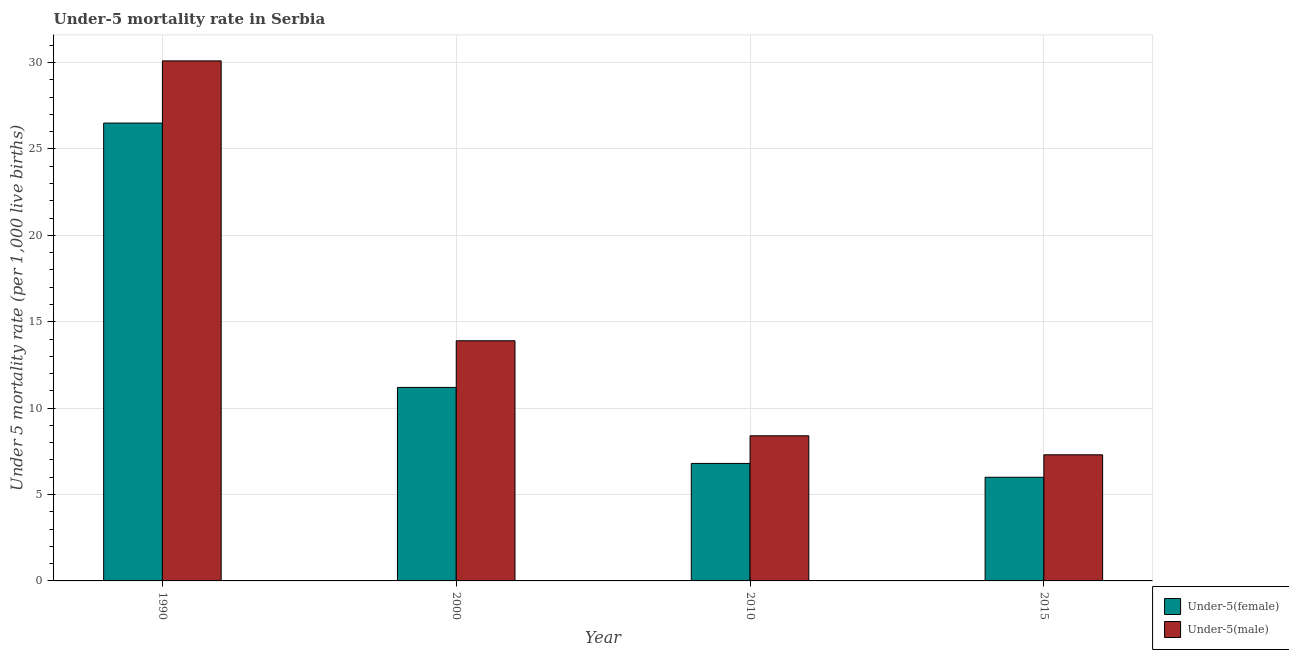How many different coloured bars are there?
Your answer should be very brief. 2. How many groups of bars are there?
Keep it short and to the point. 4. Are the number of bars per tick equal to the number of legend labels?
Provide a succinct answer. Yes. Are the number of bars on each tick of the X-axis equal?
Your answer should be compact. Yes. What is the label of the 4th group of bars from the left?
Ensure brevity in your answer.  2015. In how many cases, is the number of bars for a given year not equal to the number of legend labels?
Give a very brief answer. 0. What is the under-5 male mortality rate in 2010?
Offer a terse response. 8.4. Across all years, what is the maximum under-5 male mortality rate?
Your answer should be very brief. 30.1. In which year was the under-5 male mortality rate minimum?
Ensure brevity in your answer.  2015. What is the total under-5 female mortality rate in the graph?
Your response must be concise. 50.5. What is the difference between the under-5 male mortality rate in 2000 and that in 2015?
Give a very brief answer. 6.6. What is the difference between the under-5 male mortality rate in 1990 and the under-5 female mortality rate in 2010?
Make the answer very short. 21.7. What is the average under-5 female mortality rate per year?
Provide a succinct answer. 12.62. In the year 2010, what is the difference between the under-5 female mortality rate and under-5 male mortality rate?
Your response must be concise. 0. What is the ratio of the under-5 female mortality rate in 2010 to that in 2015?
Your answer should be very brief. 1.13. Is the difference between the under-5 female mortality rate in 1990 and 2000 greater than the difference between the under-5 male mortality rate in 1990 and 2000?
Make the answer very short. No. What is the difference between the highest and the second highest under-5 male mortality rate?
Offer a very short reply. 16.2. What is the difference between the highest and the lowest under-5 male mortality rate?
Provide a short and direct response. 22.8. In how many years, is the under-5 male mortality rate greater than the average under-5 male mortality rate taken over all years?
Give a very brief answer. 1. Is the sum of the under-5 female mortality rate in 2000 and 2015 greater than the maximum under-5 male mortality rate across all years?
Offer a very short reply. No. What does the 1st bar from the left in 2010 represents?
Provide a succinct answer. Under-5(female). What does the 2nd bar from the right in 1990 represents?
Offer a terse response. Under-5(female). How many bars are there?
Keep it short and to the point. 8. Are all the bars in the graph horizontal?
Keep it short and to the point. No. How many years are there in the graph?
Your answer should be very brief. 4. Are the values on the major ticks of Y-axis written in scientific E-notation?
Make the answer very short. No. Does the graph contain any zero values?
Ensure brevity in your answer.  No. Where does the legend appear in the graph?
Provide a succinct answer. Bottom right. How many legend labels are there?
Offer a terse response. 2. What is the title of the graph?
Provide a succinct answer. Under-5 mortality rate in Serbia. Does "Electricity" appear as one of the legend labels in the graph?
Keep it short and to the point. No. What is the label or title of the Y-axis?
Offer a terse response. Under 5 mortality rate (per 1,0 live births). What is the Under 5 mortality rate (per 1,000 live births) of Under-5(male) in 1990?
Provide a succinct answer. 30.1. What is the Under 5 mortality rate (per 1,000 live births) of Under-5(male) in 2000?
Your answer should be compact. 13.9. What is the Under 5 mortality rate (per 1,000 live births) of Under-5(female) in 2010?
Your answer should be compact. 6.8. What is the Under 5 mortality rate (per 1,000 live births) in Under-5(male) in 2010?
Your answer should be very brief. 8.4. What is the Under 5 mortality rate (per 1,000 live births) of Under-5(female) in 2015?
Make the answer very short. 6. What is the Under 5 mortality rate (per 1,000 live births) of Under-5(male) in 2015?
Keep it short and to the point. 7.3. Across all years, what is the maximum Under 5 mortality rate (per 1,000 live births) of Under-5(female)?
Offer a terse response. 26.5. Across all years, what is the maximum Under 5 mortality rate (per 1,000 live births) in Under-5(male)?
Your answer should be very brief. 30.1. Across all years, what is the minimum Under 5 mortality rate (per 1,000 live births) of Under-5(male)?
Ensure brevity in your answer.  7.3. What is the total Under 5 mortality rate (per 1,000 live births) in Under-5(female) in the graph?
Give a very brief answer. 50.5. What is the total Under 5 mortality rate (per 1,000 live births) in Under-5(male) in the graph?
Make the answer very short. 59.7. What is the difference between the Under 5 mortality rate (per 1,000 live births) in Under-5(female) in 1990 and that in 2000?
Your response must be concise. 15.3. What is the difference between the Under 5 mortality rate (per 1,000 live births) in Under-5(male) in 1990 and that in 2000?
Your response must be concise. 16.2. What is the difference between the Under 5 mortality rate (per 1,000 live births) of Under-5(male) in 1990 and that in 2010?
Keep it short and to the point. 21.7. What is the difference between the Under 5 mortality rate (per 1,000 live births) in Under-5(male) in 1990 and that in 2015?
Make the answer very short. 22.8. What is the difference between the Under 5 mortality rate (per 1,000 live births) of Under-5(female) in 2000 and that in 2010?
Provide a short and direct response. 4.4. What is the difference between the Under 5 mortality rate (per 1,000 live births) in Under-5(male) in 2000 and that in 2015?
Offer a terse response. 6.6. What is the difference between the Under 5 mortality rate (per 1,000 live births) in Under-5(female) in 2010 and that in 2015?
Give a very brief answer. 0.8. What is the difference between the Under 5 mortality rate (per 1,000 live births) of Under-5(male) in 2010 and that in 2015?
Your answer should be compact. 1.1. What is the difference between the Under 5 mortality rate (per 1,000 live births) of Under-5(female) in 1990 and the Under 5 mortality rate (per 1,000 live births) of Under-5(male) in 2000?
Your answer should be very brief. 12.6. What is the difference between the Under 5 mortality rate (per 1,000 live births) in Under-5(female) in 1990 and the Under 5 mortality rate (per 1,000 live births) in Under-5(male) in 2015?
Make the answer very short. 19.2. What is the difference between the Under 5 mortality rate (per 1,000 live births) in Under-5(female) in 2000 and the Under 5 mortality rate (per 1,000 live births) in Under-5(male) in 2015?
Offer a terse response. 3.9. What is the average Under 5 mortality rate (per 1,000 live births) of Under-5(female) per year?
Your answer should be compact. 12.62. What is the average Under 5 mortality rate (per 1,000 live births) in Under-5(male) per year?
Provide a succinct answer. 14.93. In the year 1990, what is the difference between the Under 5 mortality rate (per 1,000 live births) of Under-5(female) and Under 5 mortality rate (per 1,000 live births) of Under-5(male)?
Your answer should be very brief. -3.6. In the year 2015, what is the difference between the Under 5 mortality rate (per 1,000 live births) in Under-5(female) and Under 5 mortality rate (per 1,000 live births) in Under-5(male)?
Offer a terse response. -1.3. What is the ratio of the Under 5 mortality rate (per 1,000 live births) in Under-5(female) in 1990 to that in 2000?
Provide a short and direct response. 2.37. What is the ratio of the Under 5 mortality rate (per 1,000 live births) of Under-5(male) in 1990 to that in 2000?
Your answer should be very brief. 2.17. What is the ratio of the Under 5 mortality rate (per 1,000 live births) in Under-5(female) in 1990 to that in 2010?
Give a very brief answer. 3.9. What is the ratio of the Under 5 mortality rate (per 1,000 live births) in Under-5(male) in 1990 to that in 2010?
Your answer should be very brief. 3.58. What is the ratio of the Under 5 mortality rate (per 1,000 live births) of Under-5(female) in 1990 to that in 2015?
Keep it short and to the point. 4.42. What is the ratio of the Under 5 mortality rate (per 1,000 live births) of Under-5(male) in 1990 to that in 2015?
Provide a short and direct response. 4.12. What is the ratio of the Under 5 mortality rate (per 1,000 live births) of Under-5(female) in 2000 to that in 2010?
Make the answer very short. 1.65. What is the ratio of the Under 5 mortality rate (per 1,000 live births) of Under-5(male) in 2000 to that in 2010?
Your answer should be very brief. 1.65. What is the ratio of the Under 5 mortality rate (per 1,000 live births) of Under-5(female) in 2000 to that in 2015?
Your answer should be very brief. 1.87. What is the ratio of the Under 5 mortality rate (per 1,000 live births) of Under-5(male) in 2000 to that in 2015?
Make the answer very short. 1.9. What is the ratio of the Under 5 mortality rate (per 1,000 live births) of Under-5(female) in 2010 to that in 2015?
Ensure brevity in your answer.  1.13. What is the ratio of the Under 5 mortality rate (per 1,000 live births) of Under-5(male) in 2010 to that in 2015?
Offer a very short reply. 1.15. What is the difference between the highest and the lowest Under 5 mortality rate (per 1,000 live births) of Under-5(female)?
Your answer should be compact. 20.5. What is the difference between the highest and the lowest Under 5 mortality rate (per 1,000 live births) in Under-5(male)?
Offer a terse response. 22.8. 